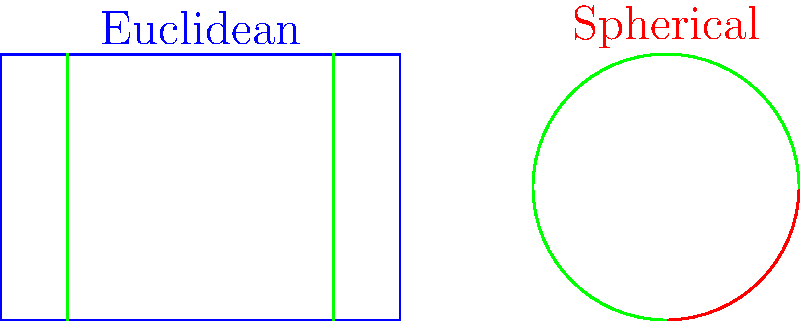In the diagram above, green lines represent "straight lines" in both Euclidean and spherical geometries. What is the key difference between these "straight lines" in the two geometries, and how does this affect parallel lines? To understand the difference between straight lines in Euclidean and spherical geometries, let's break it down step-by-step:

1. Euclidean geometry (blue square):
   - Straight lines are represented as we typically understand them: the shortest distance between two points.
   - They extend infinitely in both directions without curving.
   - Parallel lines in Euclidean geometry never intersect, no matter how far they are extended.

2. Spherical geometry (red circle):
   - "Straight lines" on a sphere are actually great circles, which are the largest circles that can be drawn on the surface of a sphere.
   - These great circles represent the shortest path between two points on the sphere's surface.
   - They appear curved when projected onto a 2D plane, as shown in the diagram.

3. Key differences:
   - Shape: Euclidean straight lines are truly straight, while spherical "straight lines" are curved when viewed from outside the sphere.
   - Extension: Euclidean lines extend infinitely, but spherical lines (great circles) eventually return to their starting point.

4. Effect on parallel lines:
   - In Euclidean geometry, parallel lines never intersect.
   - In spherical geometry, all "straight lines" (great circles) intersect at two antipodal points.
   - This means there are no truly parallel lines in spherical geometry.

5. Implications:
   - The sum of angles in a triangle is always 180° in Euclidean geometry.
   - In spherical geometry, the sum of angles in a triangle is always greater than 180°.

This fundamental difference in the nature of "straight lines" leads to many other distinctions between Euclidean and spherical geometries, affecting various geometric properties and theorems.
Answer: Euclidean straight lines are truly straight and can be parallel; spherical "straight lines" are curved (great circles) and always intersect, eliminating true parallels. 